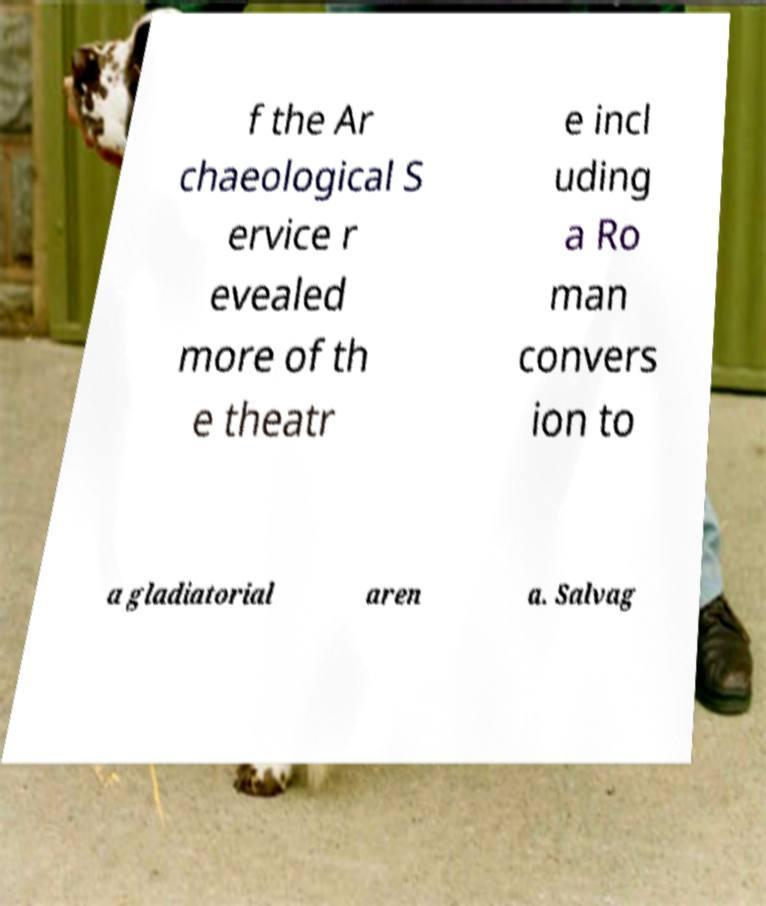For documentation purposes, I need the text within this image transcribed. Could you provide that? f the Ar chaeological S ervice r evealed more of th e theatr e incl uding a Ro man convers ion to a gladiatorial aren a. Salvag 